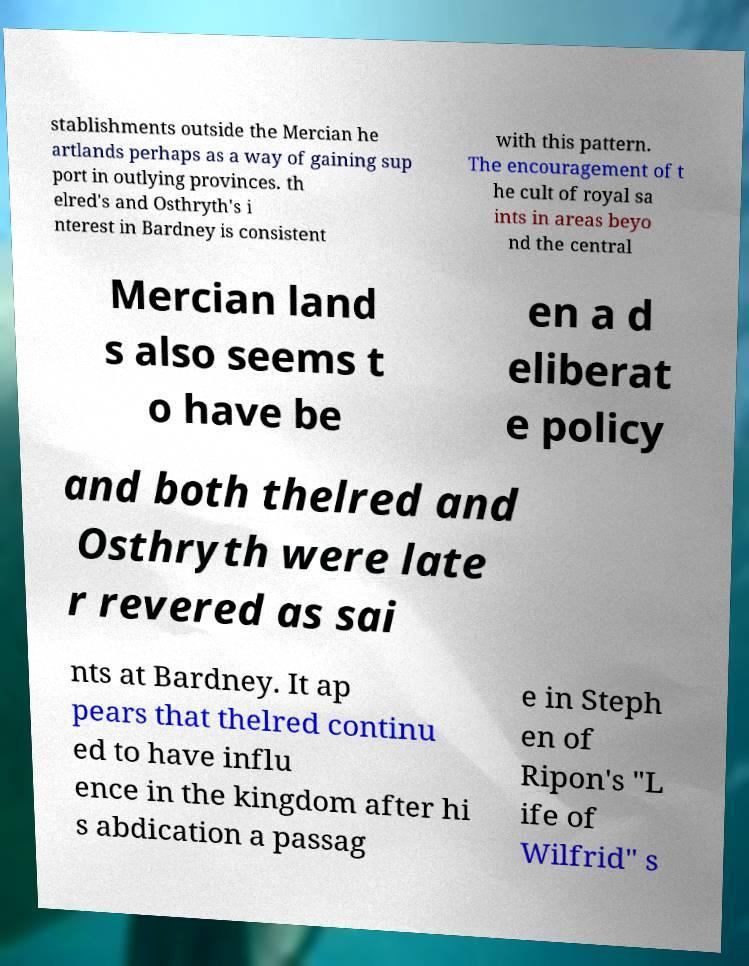Can you accurately transcribe the text from the provided image for me? stablishments outside the Mercian he artlands perhaps as a way of gaining sup port in outlying provinces. th elred's and Osthryth's i nterest in Bardney is consistent with this pattern. The encouragement of t he cult of royal sa ints in areas beyo nd the central Mercian land s also seems t o have be en a d eliberat e policy and both thelred and Osthryth were late r revered as sai nts at Bardney. It ap pears that thelred continu ed to have influ ence in the kingdom after hi s abdication a passag e in Steph en of Ripon's "L ife of Wilfrid" s 